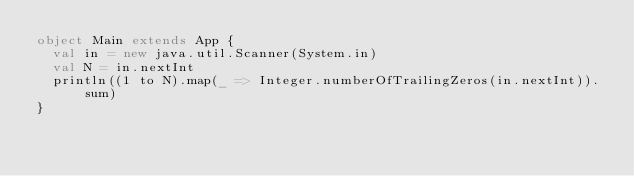Convert code to text. <code><loc_0><loc_0><loc_500><loc_500><_Scala_>object Main extends App {
  val in = new java.util.Scanner(System.in)
  val N = in.nextInt
  println((1 to N).map(_ => Integer.numberOfTrailingZeros(in.nextInt)).sum)
}</code> 